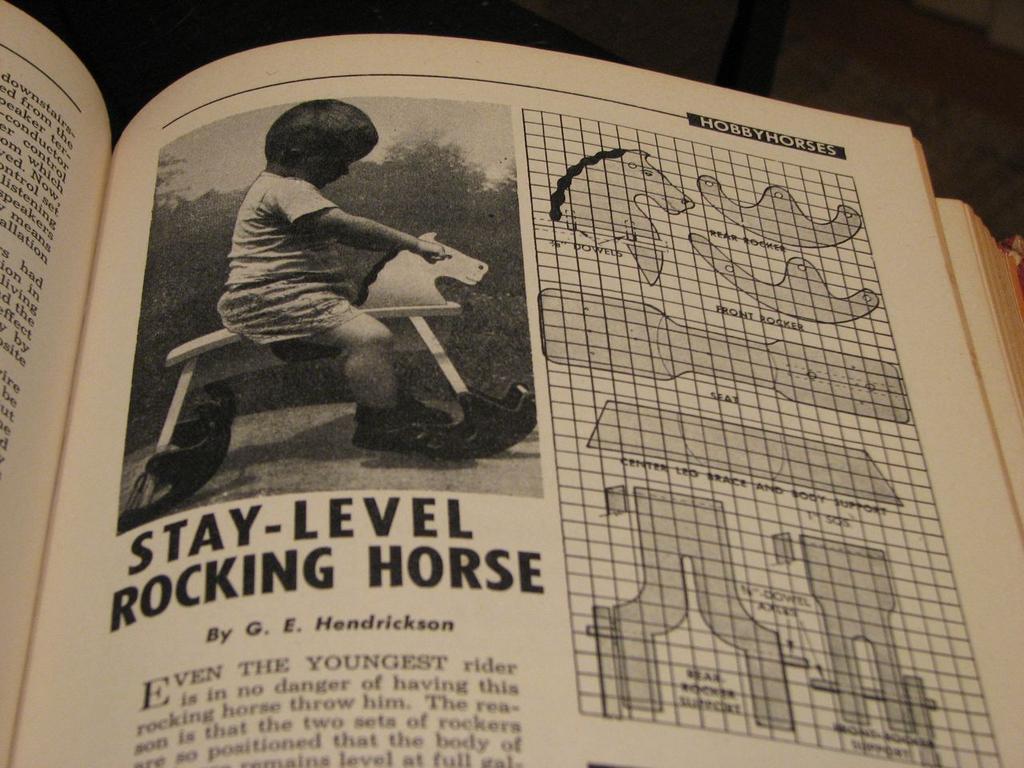How would you summarize this image in a sentence or two? This is a book and here we can see an image of a kid on the toy and there are some other pictures and some text on the paper. 